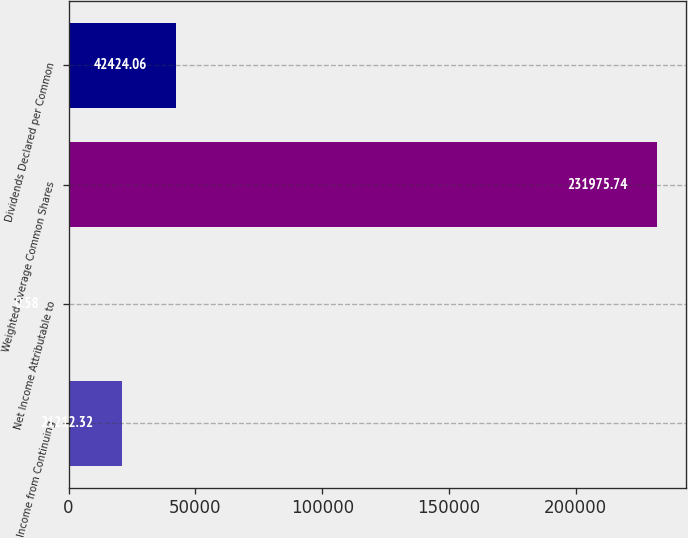Convert chart to OTSL. <chart><loc_0><loc_0><loc_500><loc_500><bar_chart><fcel>Income from Continuing<fcel>Net Income Attributable to<fcel>Weighted Average Common Shares<fcel>Dividends Declared per Common<nl><fcel>21212.3<fcel>0.58<fcel>231976<fcel>42424.1<nl></chart> 